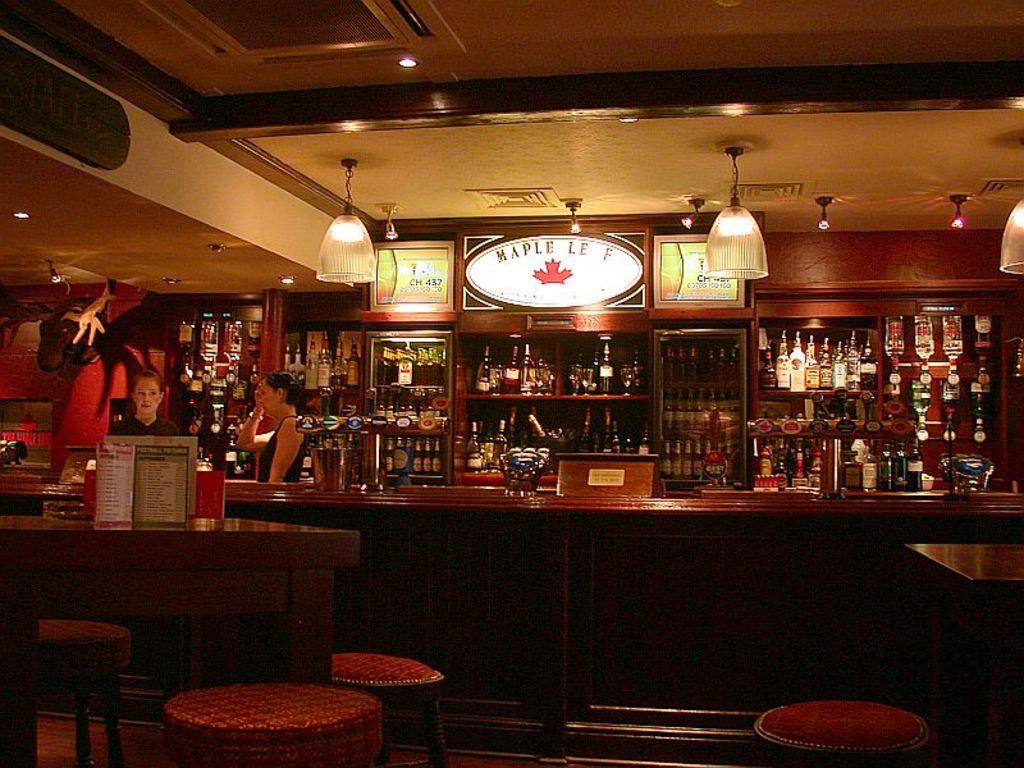Describe this image in one or two sentences. The is the picture of inside of the wine shop. There are two ladies. There is a cupboard. There is a wine bottles on the cupboard. There is a table and chairs. We can see in the background there is a lighting decoration,walls and posters. 